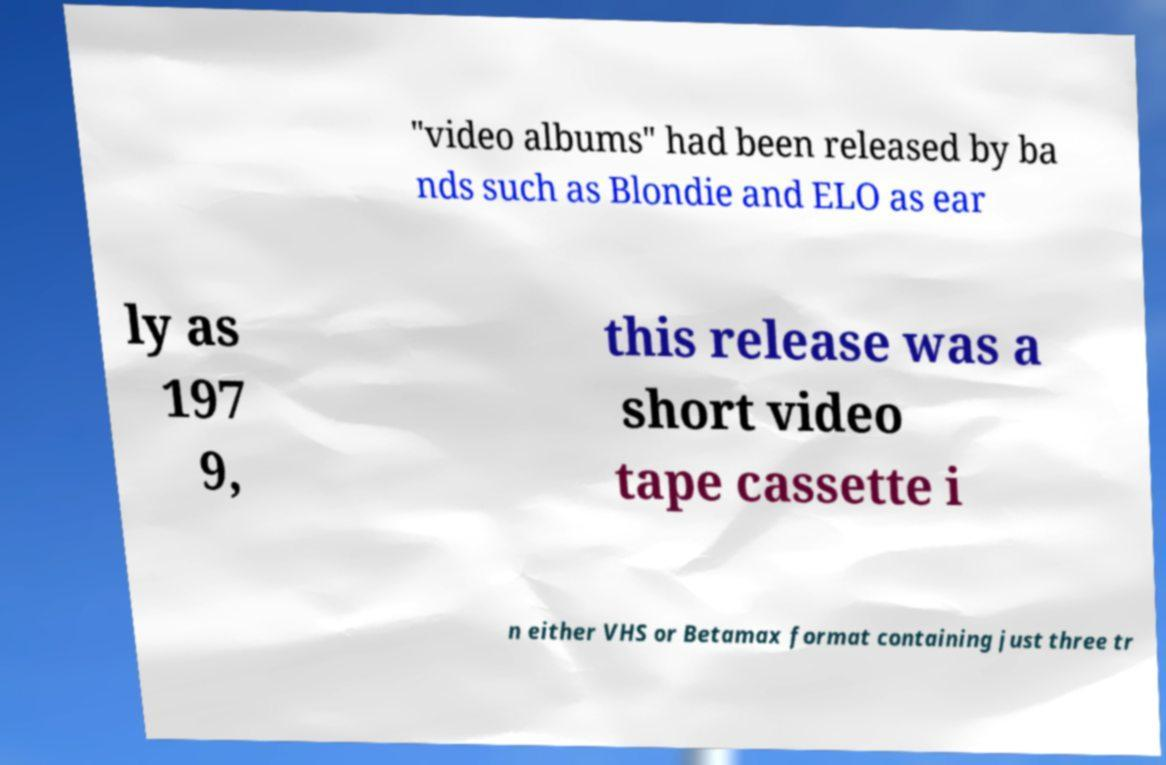For documentation purposes, I need the text within this image transcribed. Could you provide that? "video albums" had been released by ba nds such as Blondie and ELO as ear ly as 197 9, this release was a short video tape cassette i n either VHS or Betamax format containing just three tr 